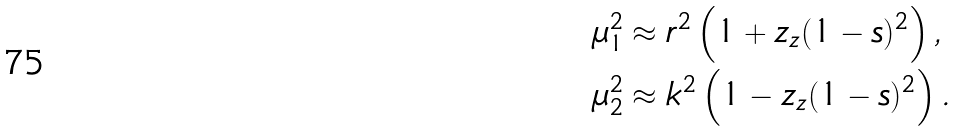Convert formula to latex. <formula><loc_0><loc_0><loc_500><loc_500>\mu _ { 1 } ^ { 2 } & \approx r ^ { 2 } \left ( 1 + z _ { z } ( 1 - s ) ^ { 2 } \right ) , \\ \mu _ { 2 } ^ { 2 } & \approx k ^ { 2 } \left ( 1 - z _ { z } ( 1 - s ) ^ { 2 } \right ) .</formula> 